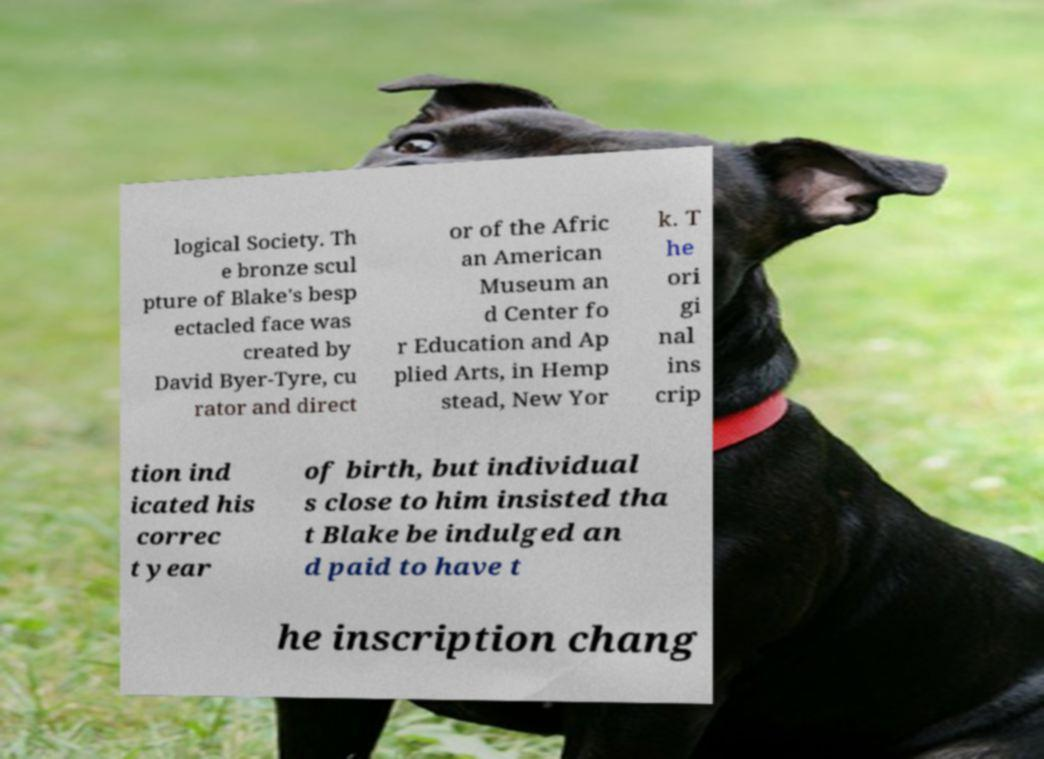I need the written content from this picture converted into text. Can you do that? logical Society. Th e bronze scul pture of Blake's besp ectacled face was created by David Byer-Tyre, cu rator and direct or of the Afric an American Museum an d Center fo r Education and Ap plied Arts, in Hemp stead, New Yor k. T he ori gi nal ins crip tion ind icated his correc t year of birth, but individual s close to him insisted tha t Blake be indulged an d paid to have t he inscription chang 